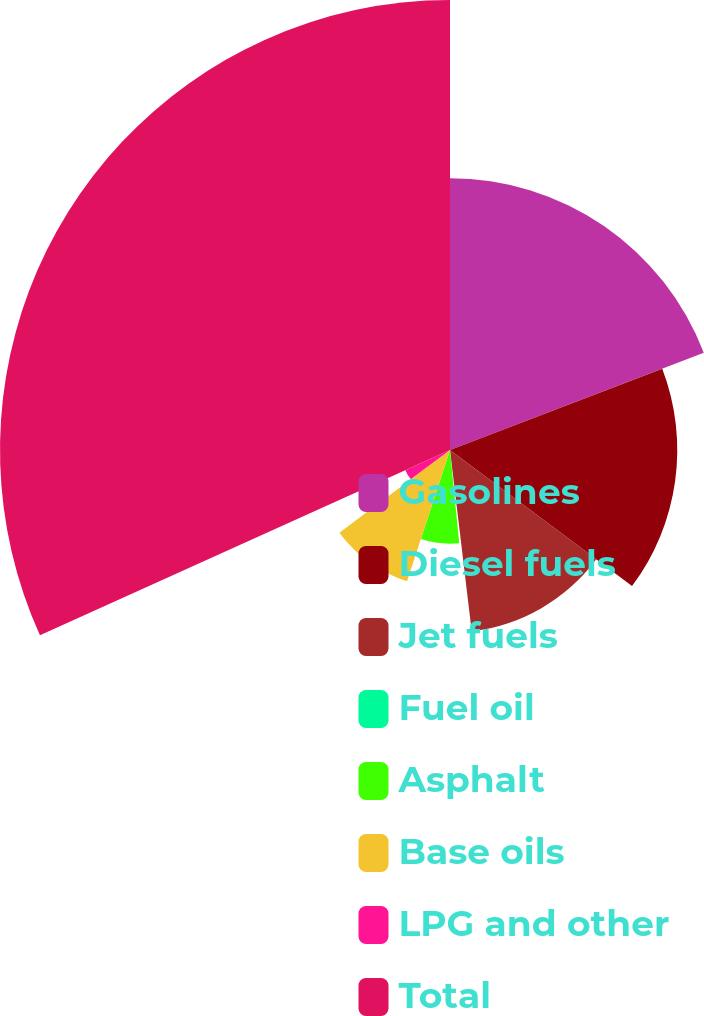Convert chart. <chart><loc_0><loc_0><loc_500><loc_500><pie_chart><fcel>Gasolines<fcel>Diesel fuels<fcel>Jet fuels<fcel>Fuel oil<fcel>Asphalt<fcel>Base oils<fcel>LPG and other<fcel>Total<nl><fcel>19.18%<fcel>16.04%<fcel>12.89%<fcel>0.32%<fcel>6.61%<fcel>9.75%<fcel>3.46%<fcel>31.76%<nl></chart> 